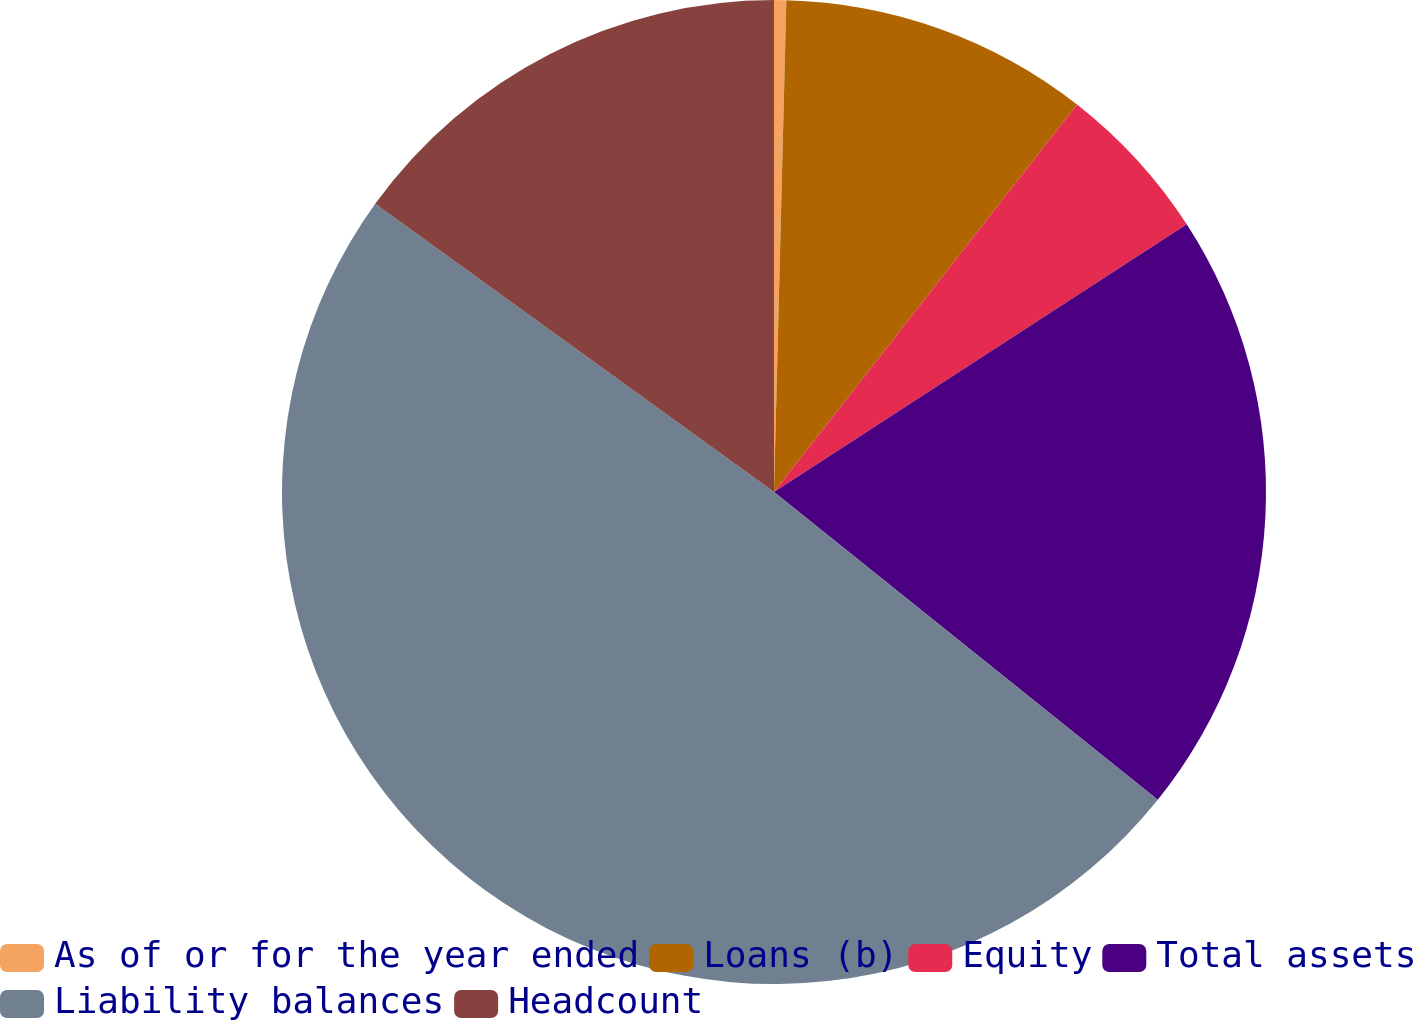Convert chart. <chart><loc_0><loc_0><loc_500><loc_500><pie_chart><fcel>As of or for the year ended<fcel>Loans (b)<fcel>Equity<fcel>Total assets<fcel>Liability balances<fcel>Headcount<nl><fcel>0.4%<fcel>10.16%<fcel>5.28%<fcel>19.92%<fcel>49.2%<fcel>15.04%<nl></chart> 